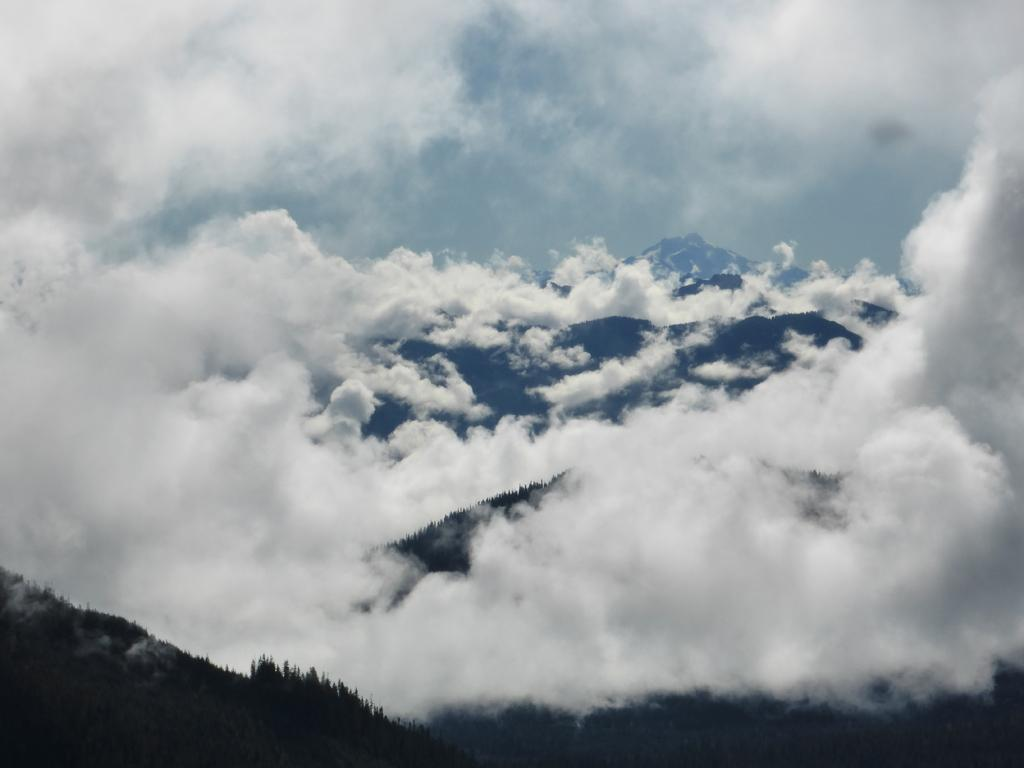What type of natural landform can be seen in the image? There are mountains in the image. What type of vegetation is present in the image? Trees are visible in the image. How are the trees in the image affected by the weather? The trees are covered with clouds in the image. What type of book is being read by the bushes in the image? There are no bushes or books present in the image. 